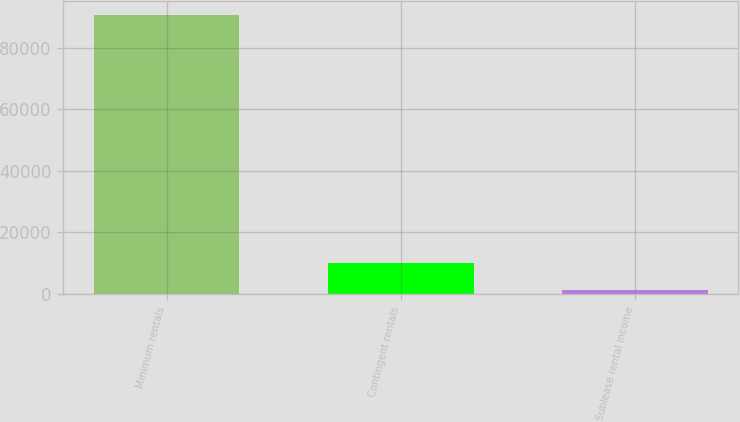Convert chart to OTSL. <chart><loc_0><loc_0><loc_500><loc_500><bar_chart><fcel>Minimum rentals<fcel>Contingent rentals<fcel>Sublease rental income<nl><fcel>90547<fcel>10135.6<fcel>1201<nl></chart> 